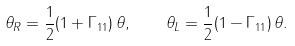Convert formula to latex. <formula><loc_0><loc_0><loc_500><loc_500>\theta _ { R } = { \frac { 1 } { 2 } } ( 1 + \Gamma _ { 1 1 } ) \, \theta , \quad \theta _ { L } = { \frac { 1 } { 2 } } ( 1 - \Gamma _ { 1 1 } ) \, \theta .</formula> 